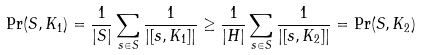<formula> <loc_0><loc_0><loc_500><loc_500>{ \Pr } ( S , K _ { 1 } ) = \frac { 1 } { | S | } \sum _ { s \in S } \frac { 1 } { | [ s , K _ { 1 } ] | } \geq \frac { 1 } { | H | } \sum _ { s \in S } \frac { 1 } { | [ s , K _ { 2 } ] | } = { \Pr } ( S , K _ { 2 } )</formula> 